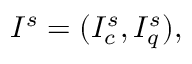<formula> <loc_0><loc_0><loc_500><loc_500>I ^ { s } = ( I _ { c } ^ { s } , I _ { q } ^ { s } ) ,</formula> 